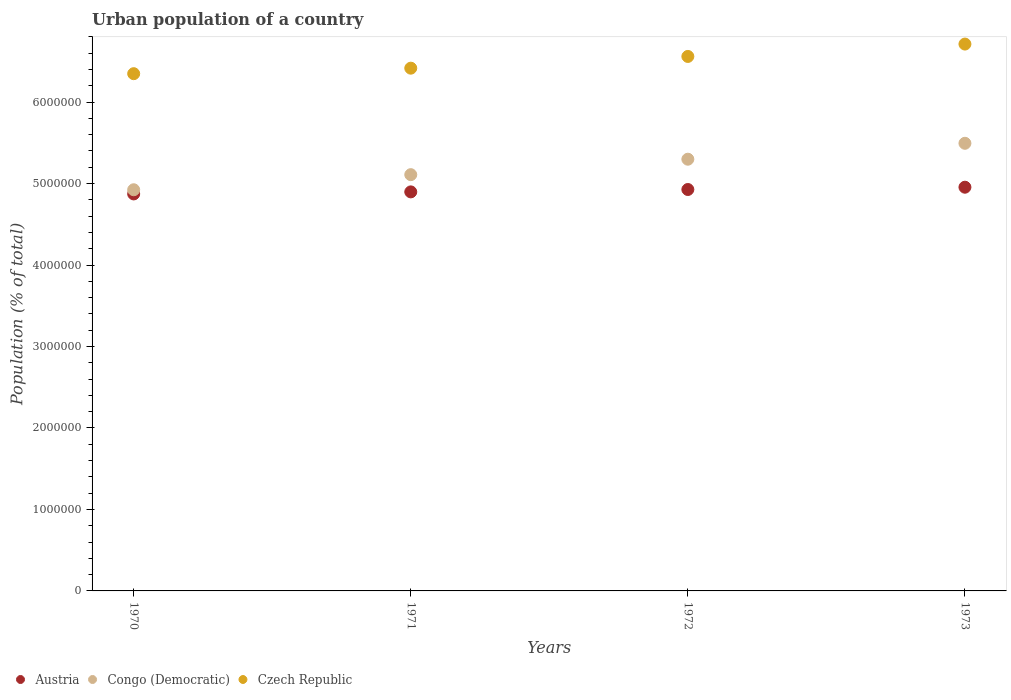What is the urban population in Czech Republic in 1972?
Your answer should be compact. 6.56e+06. Across all years, what is the maximum urban population in Congo (Democratic)?
Your response must be concise. 5.49e+06. Across all years, what is the minimum urban population in Czech Republic?
Offer a very short reply. 6.35e+06. In which year was the urban population in Czech Republic maximum?
Offer a very short reply. 1973. What is the total urban population in Czech Republic in the graph?
Your answer should be compact. 2.60e+07. What is the difference between the urban population in Czech Republic in 1972 and that in 1973?
Your answer should be compact. -1.52e+05. What is the difference between the urban population in Austria in 1971 and the urban population in Congo (Democratic) in 1972?
Make the answer very short. -4.01e+05. What is the average urban population in Congo (Democratic) per year?
Provide a succinct answer. 5.21e+06. In the year 1972, what is the difference between the urban population in Congo (Democratic) and urban population in Austria?
Give a very brief answer. 3.72e+05. What is the ratio of the urban population in Czech Republic in 1972 to that in 1973?
Your answer should be compact. 0.98. Is the urban population in Czech Republic in 1970 less than that in 1971?
Keep it short and to the point. Yes. Is the difference between the urban population in Congo (Democratic) in 1972 and 1973 greater than the difference between the urban population in Austria in 1972 and 1973?
Your answer should be very brief. No. What is the difference between the highest and the second highest urban population in Congo (Democratic)?
Offer a very short reply. 1.95e+05. What is the difference between the highest and the lowest urban population in Czech Republic?
Provide a short and direct response. 3.64e+05. In how many years, is the urban population in Czech Republic greater than the average urban population in Czech Republic taken over all years?
Your answer should be compact. 2. Does the urban population in Czech Republic monotonically increase over the years?
Keep it short and to the point. Yes. Is the urban population in Austria strictly less than the urban population in Czech Republic over the years?
Provide a short and direct response. Yes. How many years are there in the graph?
Provide a succinct answer. 4. Are the values on the major ticks of Y-axis written in scientific E-notation?
Keep it short and to the point. No. Does the graph contain grids?
Make the answer very short. No. How many legend labels are there?
Make the answer very short. 3. How are the legend labels stacked?
Make the answer very short. Horizontal. What is the title of the graph?
Give a very brief answer. Urban population of a country. What is the label or title of the Y-axis?
Keep it short and to the point. Population (% of total). What is the Population (% of total) of Austria in 1970?
Your answer should be very brief. 4.87e+06. What is the Population (% of total) of Congo (Democratic) in 1970?
Ensure brevity in your answer.  4.92e+06. What is the Population (% of total) in Czech Republic in 1970?
Give a very brief answer. 6.35e+06. What is the Population (% of total) of Austria in 1971?
Keep it short and to the point. 4.90e+06. What is the Population (% of total) in Congo (Democratic) in 1971?
Your response must be concise. 5.11e+06. What is the Population (% of total) of Czech Republic in 1971?
Make the answer very short. 6.42e+06. What is the Population (% of total) in Austria in 1972?
Keep it short and to the point. 4.93e+06. What is the Population (% of total) of Congo (Democratic) in 1972?
Your answer should be compact. 5.30e+06. What is the Population (% of total) of Czech Republic in 1972?
Ensure brevity in your answer.  6.56e+06. What is the Population (% of total) of Austria in 1973?
Your response must be concise. 4.96e+06. What is the Population (% of total) of Congo (Democratic) in 1973?
Your response must be concise. 5.49e+06. What is the Population (% of total) in Czech Republic in 1973?
Keep it short and to the point. 6.71e+06. Across all years, what is the maximum Population (% of total) in Austria?
Offer a terse response. 4.96e+06. Across all years, what is the maximum Population (% of total) of Congo (Democratic)?
Ensure brevity in your answer.  5.49e+06. Across all years, what is the maximum Population (% of total) in Czech Republic?
Offer a very short reply. 6.71e+06. Across all years, what is the minimum Population (% of total) of Austria?
Give a very brief answer. 4.87e+06. Across all years, what is the minimum Population (% of total) of Congo (Democratic)?
Make the answer very short. 4.92e+06. Across all years, what is the minimum Population (% of total) in Czech Republic?
Offer a very short reply. 6.35e+06. What is the total Population (% of total) of Austria in the graph?
Offer a terse response. 1.97e+07. What is the total Population (% of total) in Congo (Democratic) in the graph?
Keep it short and to the point. 2.08e+07. What is the total Population (% of total) in Czech Republic in the graph?
Your response must be concise. 2.60e+07. What is the difference between the Population (% of total) in Austria in 1970 and that in 1971?
Make the answer very short. -2.50e+04. What is the difference between the Population (% of total) in Congo (Democratic) in 1970 and that in 1971?
Offer a very short reply. -1.85e+05. What is the difference between the Population (% of total) of Czech Republic in 1970 and that in 1971?
Give a very brief answer. -6.76e+04. What is the difference between the Population (% of total) in Austria in 1970 and that in 1972?
Your response must be concise. -5.43e+04. What is the difference between the Population (% of total) of Congo (Democratic) in 1970 and that in 1972?
Ensure brevity in your answer.  -3.75e+05. What is the difference between the Population (% of total) in Czech Republic in 1970 and that in 1972?
Make the answer very short. -2.12e+05. What is the difference between the Population (% of total) of Austria in 1970 and that in 1973?
Make the answer very short. -8.25e+04. What is the difference between the Population (% of total) of Congo (Democratic) in 1970 and that in 1973?
Ensure brevity in your answer.  -5.70e+05. What is the difference between the Population (% of total) of Czech Republic in 1970 and that in 1973?
Keep it short and to the point. -3.64e+05. What is the difference between the Population (% of total) in Austria in 1971 and that in 1972?
Offer a terse response. -2.93e+04. What is the difference between the Population (% of total) of Congo (Democratic) in 1971 and that in 1972?
Offer a terse response. -1.90e+05. What is the difference between the Population (% of total) in Czech Republic in 1971 and that in 1972?
Give a very brief answer. -1.44e+05. What is the difference between the Population (% of total) of Austria in 1971 and that in 1973?
Give a very brief answer. -5.74e+04. What is the difference between the Population (% of total) of Congo (Democratic) in 1971 and that in 1973?
Your response must be concise. -3.85e+05. What is the difference between the Population (% of total) of Czech Republic in 1971 and that in 1973?
Offer a very short reply. -2.96e+05. What is the difference between the Population (% of total) of Austria in 1972 and that in 1973?
Make the answer very short. -2.81e+04. What is the difference between the Population (% of total) in Congo (Democratic) in 1972 and that in 1973?
Offer a very short reply. -1.95e+05. What is the difference between the Population (% of total) of Czech Republic in 1972 and that in 1973?
Keep it short and to the point. -1.52e+05. What is the difference between the Population (% of total) of Austria in 1970 and the Population (% of total) of Congo (Democratic) in 1971?
Provide a short and direct response. -2.36e+05. What is the difference between the Population (% of total) in Austria in 1970 and the Population (% of total) in Czech Republic in 1971?
Offer a very short reply. -1.54e+06. What is the difference between the Population (% of total) of Congo (Democratic) in 1970 and the Population (% of total) of Czech Republic in 1971?
Keep it short and to the point. -1.49e+06. What is the difference between the Population (% of total) in Austria in 1970 and the Population (% of total) in Congo (Democratic) in 1972?
Your answer should be compact. -4.26e+05. What is the difference between the Population (% of total) of Austria in 1970 and the Population (% of total) of Czech Republic in 1972?
Ensure brevity in your answer.  -1.69e+06. What is the difference between the Population (% of total) of Congo (Democratic) in 1970 and the Population (% of total) of Czech Republic in 1972?
Ensure brevity in your answer.  -1.64e+06. What is the difference between the Population (% of total) of Austria in 1970 and the Population (% of total) of Congo (Democratic) in 1973?
Your answer should be compact. -6.22e+05. What is the difference between the Population (% of total) of Austria in 1970 and the Population (% of total) of Czech Republic in 1973?
Provide a succinct answer. -1.84e+06. What is the difference between the Population (% of total) of Congo (Democratic) in 1970 and the Population (% of total) of Czech Republic in 1973?
Offer a very short reply. -1.79e+06. What is the difference between the Population (% of total) in Austria in 1971 and the Population (% of total) in Congo (Democratic) in 1972?
Make the answer very short. -4.01e+05. What is the difference between the Population (% of total) in Austria in 1971 and the Population (% of total) in Czech Republic in 1972?
Keep it short and to the point. -1.66e+06. What is the difference between the Population (% of total) in Congo (Democratic) in 1971 and the Population (% of total) in Czech Republic in 1972?
Your response must be concise. -1.45e+06. What is the difference between the Population (% of total) in Austria in 1971 and the Population (% of total) in Congo (Democratic) in 1973?
Give a very brief answer. -5.97e+05. What is the difference between the Population (% of total) in Austria in 1971 and the Population (% of total) in Czech Republic in 1973?
Make the answer very short. -1.81e+06. What is the difference between the Population (% of total) of Congo (Democratic) in 1971 and the Population (% of total) of Czech Republic in 1973?
Your answer should be compact. -1.60e+06. What is the difference between the Population (% of total) of Austria in 1972 and the Population (% of total) of Congo (Democratic) in 1973?
Ensure brevity in your answer.  -5.67e+05. What is the difference between the Population (% of total) of Austria in 1972 and the Population (% of total) of Czech Republic in 1973?
Offer a very short reply. -1.79e+06. What is the difference between the Population (% of total) of Congo (Democratic) in 1972 and the Population (% of total) of Czech Republic in 1973?
Offer a terse response. -1.41e+06. What is the average Population (% of total) in Austria per year?
Your answer should be compact. 4.91e+06. What is the average Population (% of total) in Congo (Democratic) per year?
Provide a succinct answer. 5.21e+06. What is the average Population (% of total) in Czech Republic per year?
Offer a terse response. 6.51e+06. In the year 1970, what is the difference between the Population (% of total) in Austria and Population (% of total) in Congo (Democratic)?
Make the answer very short. -5.12e+04. In the year 1970, what is the difference between the Population (% of total) in Austria and Population (% of total) in Czech Republic?
Ensure brevity in your answer.  -1.48e+06. In the year 1970, what is the difference between the Population (% of total) of Congo (Democratic) and Population (% of total) of Czech Republic?
Your answer should be compact. -1.42e+06. In the year 1971, what is the difference between the Population (% of total) of Austria and Population (% of total) of Congo (Democratic)?
Your response must be concise. -2.11e+05. In the year 1971, what is the difference between the Population (% of total) of Austria and Population (% of total) of Czech Republic?
Your response must be concise. -1.52e+06. In the year 1971, what is the difference between the Population (% of total) of Congo (Democratic) and Population (% of total) of Czech Republic?
Offer a very short reply. -1.31e+06. In the year 1972, what is the difference between the Population (% of total) in Austria and Population (% of total) in Congo (Democratic)?
Ensure brevity in your answer.  -3.72e+05. In the year 1972, what is the difference between the Population (% of total) in Austria and Population (% of total) in Czech Republic?
Give a very brief answer. -1.63e+06. In the year 1972, what is the difference between the Population (% of total) in Congo (Democratic) and Population (% of total) in Czech Republic?
Your answer should be compact. -1.26e+06. In the year 1973, what is the difference between the Population (% of total) of Austria and Population (% of total) of Congo (Democratic)?
Ensure brevity in your answer.  -5.39e+05. In the year 1973, what is the difference between the Population (% of total) in Austria and Population (% of total) in Czech Republic?
Your answer should be very brief. -1.76e+06. In the year 1973, what is the difference between the Population (% of total) of Congo (Democratic) and Population (% of total) of Czech Republic?
Offer a terse response. -1.22e+06. What is the ratio of the Population (% of total) of Congo (Democratic) in 1970 to that in 1971?
Your answer should be compact. 0.96. What is the ratio of the Population (% of total) in Czech Republic in 1970 to that in 1971?
Give a very brief answer. 0.99. What is the ratio of the Population (% of total) in Congo (Democratic) in 1970 to that in 1972?
Offer a very short reply. 0.93. What is the ratio of the Population (% of total) of Austria in 1970 to that in 1973?
Make the answer very short. 0.98. What is the ratio of the Population (% of total) of Congo (Democratic) in 1970 to that in 1973?
Offer a terse response. 0.9. What is the ratio of the Population (% of total) in Czech Republic in 1970 to that in 1973?
Make the answer very short. 0.95. What is the ratio of the Population (% of total) of Congo (Democratic) in 1971 to that in 1972?
Provide a succinct answer. 0.96. What is the ratio of the Population (% of total) of Czech Republic in 1971 to that in 1972?
Make the answer very short. 0.98. What is the ratio of the Population (% of total) of Austria in 1971 to that in 1973?
Give a very brief answer. 0.99. What is the ratio of the Population (% of total) of Congo (Democratic) in 1971 to that in 1973?
Keep it short and to the point. 0.93. What is the ratio of the Population (% of total) of Czech Republic in 1971 to that in 1973?
Ensure brevity in your answer.  0.96. What is the ratio of the Population (% of total) in Congo (Democratic) in 1972 to that in 1973?
Give a very brief answer. 0.96. What is the ratio of the Population (% of total) in Czech Republic in 1972 to that in 1973?
Your answer should be compact. 0.98. What is the difference between the highest and the second highest Population (% of total) of Austria?
Your response must be concise. 2.81e+04. What is the difference between the highest and the second highest Population (% of total) of Congo (Democratic)?
Provide a short and direct response. 1.95e+05. What is the difference between the highest and the second highest Population (% of total) of Czech Republic?
Your response must be concise. 1.52e+05. What is the difference between the highest and the lowest Population (% of total) of Austria?
Provide a succinct answer. 8.25e+04. What is the difference between the highest and the lowest Population (% of total) in Congo (Democratic)?
Offer a very short reply. 5.70e+05. What is the difference between the highest and the lowest Population (% of total) in Czech Republic?
Offer a terse response. 3.64e+05. 